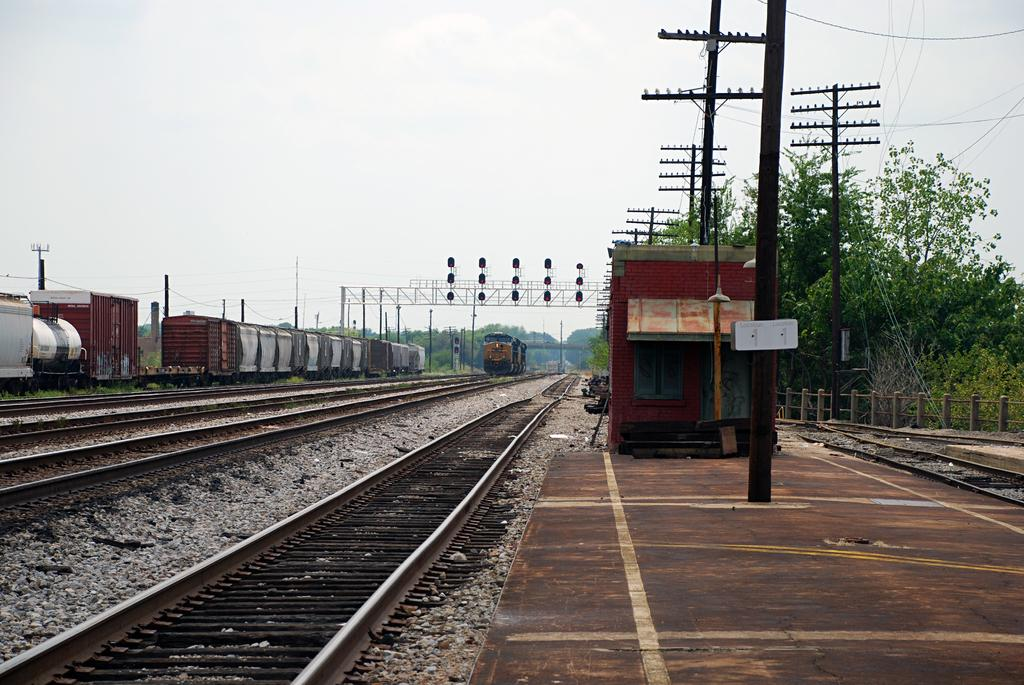What is the main subject of the image? The main subject of the image is trains on railway tracks. What can be seen beside the railway tracks? There are poles, trees, and traffic signals beside the railway tracks. What is visible in the background of the image? The sky is visible in the background of the image. Can you see a bird flying near the volcano in the image? There is no bird or volcano present in the image; it features trains on railway tracks with poles, trees, traffic signals, and a visible sky in the background. 